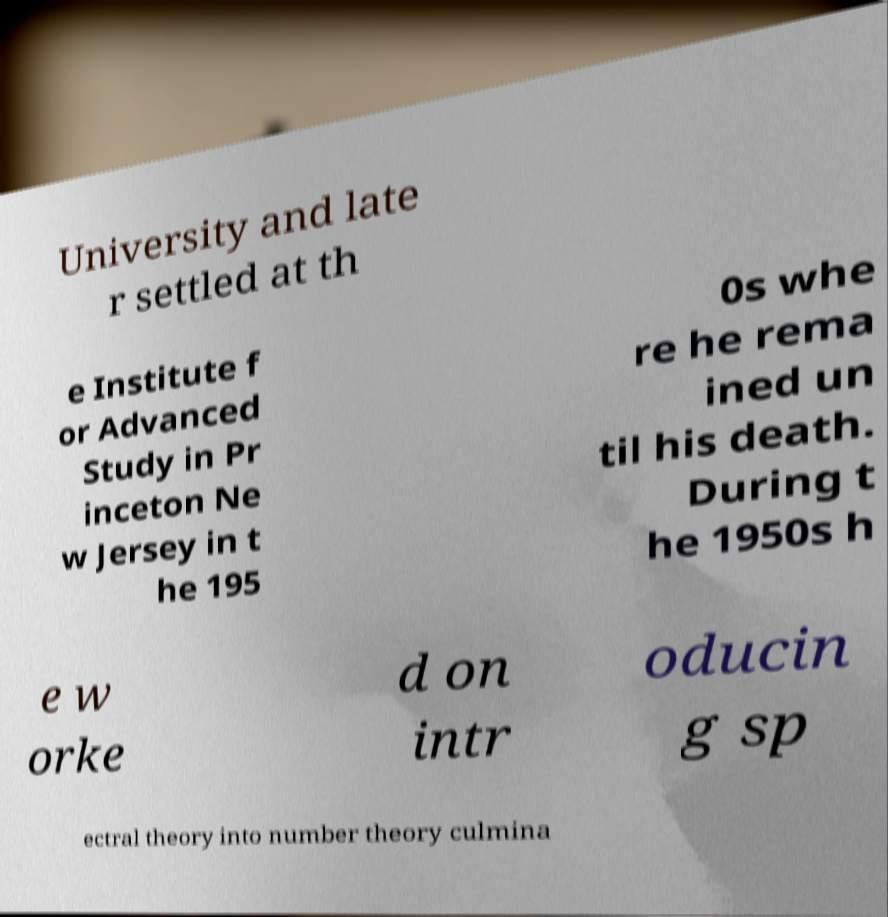I need the written content from this picture converted into text. Can you do that? University and late r settled at th e Institute f or Advanced Study in Pr inceton Ne w Jersey in t he 195 0s whe re he rema ined un til his death. During t he 1950s h e w orke d on intr oducin g sp ectral theory into number theory culmina 